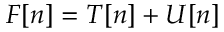<formula> <loc_0><loc_0><loc_500><loc_500>F [ n ] = T [ n ] + U [ n ]</formula> 